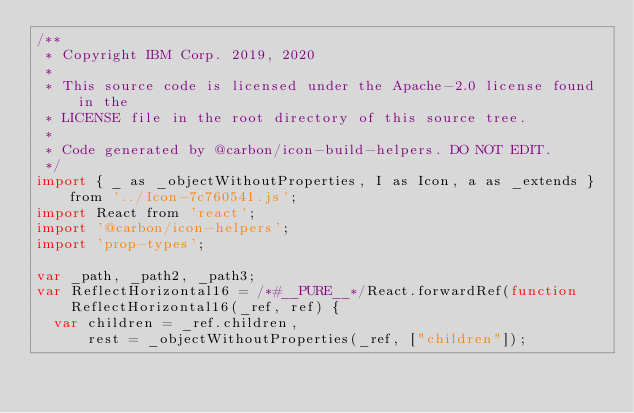Convert code to text. <code><loc_0><loc_0><loc_500><loc_500><_JavaScript_>/**
 * Copyright IBM Corp. 2019, 2020
 *
 * This source code is licensed under the Apache-2.0 license found in the
 * LICENSE file in the root directory of this source tree.
 *
 * Code generated by @carbon/icon-build-helpers. DO NOT EDIT.
 */
import { _ as _objectWithoutProperties, I as Icon, a as _extends } from '../Icon-7c760541.js';
import React from 'react';
import '@carbon/icon-helpers';
import 'prop-types';

var _path, _path2, _path3;
var ReflectHorizontal16 = /*#__PURE__*/React.forwardRef(function ReflectHorizontal16(_ref, ref) {
  var children = _ref.children,
      rest = _objectWithoutProperties(_ref, ["children"]);
</code> 